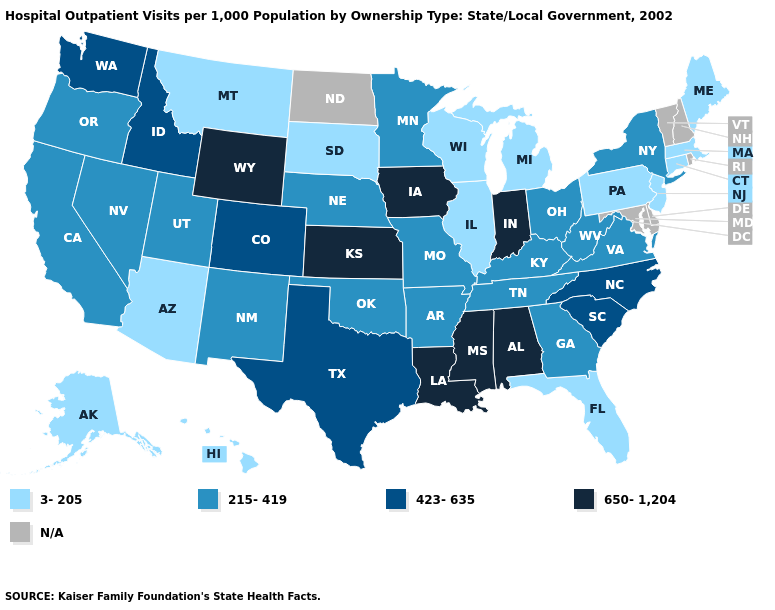What is the value of Louisiana?
Keep it brief. 650-1,204. Which states have the highest value in the USA?
Keep it brief. Alabama, Indiana, Iowa, Kansas, Louisiana, Mississippi, Wyoming. Does Pennsylvania have the highest value in the Northeast?
Keep it brief. No. Name the states that have a value in the range 650-1,204?
Write a very short answer. Alabama, Indiana, Iowa, Kansas, Louisiana, Mississippi, Wyoming. Name the states that have a value in the range N/A?
Give a very brief answer. Delaware, Maryland, New Hampshire, North Dakota, Rhode Island, Vermont. What is the value of Kentucky?
Concise answer only. 215-419. What is the value of Arizona?
Answer briefly. 3-205. Does Iowa have the lowest value in the USA?
Quick response, please. No. Name the states that have a value in the range 215-419?
Quick response, please. Arkansas, California, Georgia, Kentucky, Minnesota, Missouri, Nebraska, Nevada, New Mexico, New York, Ohio, Oklahoma, Oregon, Tennessee, Utah, Virginia, West Virginia. Name the states that have a value in the range 650-1,204?
Write a very short answer. Alabama, Indiana, Iowa, Kansas, Louisiana, Mississippi, Wyoming. What is the value of Alabama?
Be succinct. 650-1,204. Does the first symbol in the legend represent the smallest category?
Be succinct. Yes. Does Wyoming have the highest value in the West?
Quick response, please. Yes. Name the states that have a value in the range 423-635?
Concise answer only. Colorado, Idaho, North Carolina, South Carolina, Texas, Washington. 